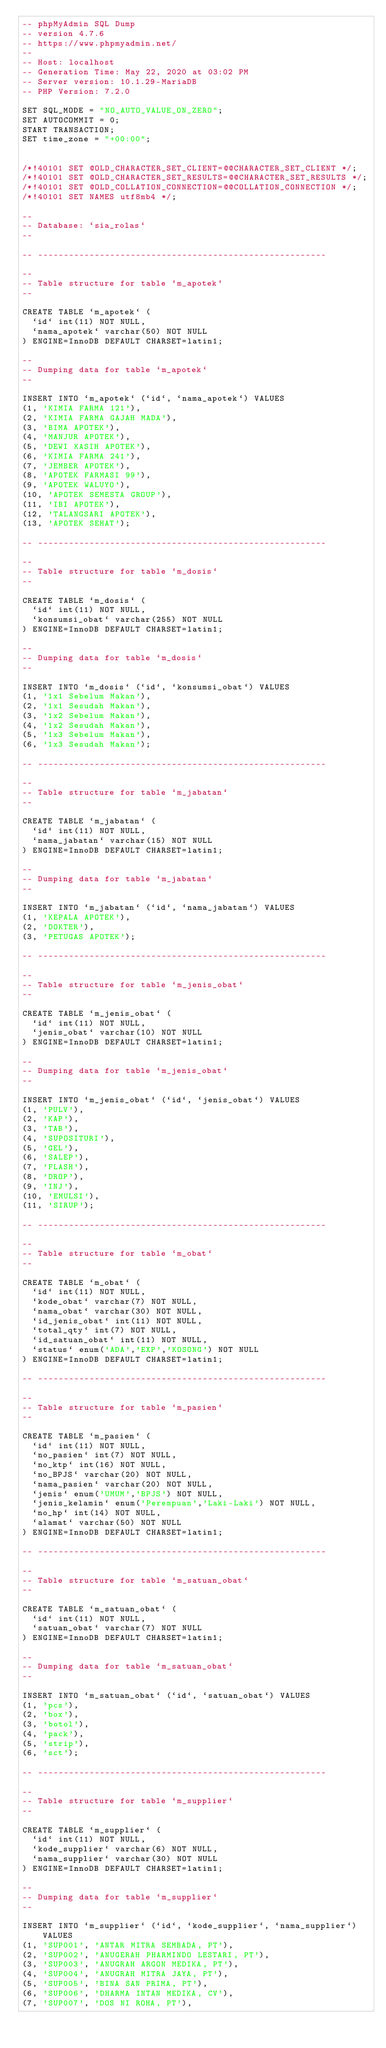Convert code to text. <code><loc_0><loc_0><loc_500><loc_500><_SQL_>-- phpMyAdmin SQL Dump
-- version 4.7.6
-- https://www.phpmyadmin.net/
--
-- Host: localhost
-- Generation Time: May 22, 2020 at 03:02 PM
-- Server version: 10.1.29-MariaDB
-- PHP Version: 7.2.0

SET SQL_MODE = "NO_AUTO_VALUE_ON_ZERO";
SET AUTOCOMMIT = 0;
START TRANSACTION;
SET time_zone = "+00:00";


/*!40101 SET @OLD_CHARACTER_SET_CLIENT=@@CHARACTER_SET_CLIENT */;
/*!40101 SET @OLD_CHARACTER_SET_RESULTS=@@CHARACTER_SET_RESULTS */;
/*!40101 SET @OLD_COLLATION_CONNECTION=@@COLLATION_CONNECTION */;
/*!40101 SET NAMES utf8mb4 */;

--
-- Database: `sia_rolas`
--

-- --------------------------------------------------------

--
-- Table structure for table `m_apotek`
--

CREATE TABLE `m_apotek` (
  `id` int(11) NOT NULL,
  `nama_apotek` varchar(50) NOT NULL
) ENGINE=InnoDB DEFAULT CHARSET=latin1;

--
-- Dumping data for table `m_apotek`
--

INSERT INTO `m_apotek` (`id`, `nama_apotek`) VALUES
(1, 'KIMIA FARMA 121'),
(2, 'KIMIA FARMA GAJAH MADA'),
(3, 'BIMA APOTEK'),
(4, 'MANJUR APOTEK'),
(5, 'DEWI KASIH APOTEK'),
(6, 'KIMIA FARMA 241'),
(7, 'JEMBER APOTEK'),
(8, 'APOTEK FARMASI 99'),
(9, 'APOTEK WALUYO'),
(10, 'APOTEK SEMESTA GROUP'),
(11, 'IBI APOTEK'),
(12, 'TALANGSARI APOTEK'),
(13, 'APOTEK SEHAT');

-- --------------------------------------------------------

--
-- Table structure for table `m_dosis`
--

CREATE TABLE `m_dosis` (
  `id` int(11) NOT NULL,
  `konsumsi_obat` varchar(255) NOT NULL
) ENGINE=InnoDB DEFAULT CHARSET=latin1;

--
-- Dumping data for table `m_dosis`
--

INSERT INTO `m_dosis` (`id`, `konsumsi_obat`) VALUES
(1, '1x1 Sebelum Makan'),
(2, '1x1 Sesudah Makan'),
(3, '1x2 Sebelum Makan'),
(4, '1x2 Sesudah Makan'),
(5, '1x3 Sebelum Makan'),
(6, '1x3 Sesudah Makan');

-- --------------------------------------------------------

--
-- Table structure for table `m_jabatan`
--

CREATE TABLE `m_jabatan` (
  `id` int(11) NOT NULL,
  `nama_jabatan` varchar(15) NOT NULL
) ENGINE=InnoDB DEFAULT CHARSET=latin1;

--
-- Dumping data for table `m_jabatan`
--

INSERT INTO `m_jabatan` (`id`, `nama_jabatan`) VALUES
(1, 'KEPALA APOTEK'),
(2, 'DOKTER'),
(3, 'PETUGAS APOTEK');

-- --------------------------------------------------------

--
-- Table structure for table `m_jenis_obat`
--

CREATE TABLE `m_jenis_obat` (
  `id` int(11) NOT NULL,
  `jenis_obat` varchar(10) NOT NULL
) ENGINE=InnoDB DEFAULT CHARSET=latin1;

--
-- Dumping data for table `m_jenis_obat`
--

INSERT INTO `m_jenis_obat` (`id`, `jenis_obat`) VALUES
(1, 'PULV'),
(2, 'KAP'),
(3, 'TAB'),
(4, 'SUPOSITURI'),
(5, 'GEL'),
(6, 'SALEP'),
(7, 'FLASH'),
(8, 'DROP'),
(9, 'INJ'),
(10, 'EMULSI'),
(11, 'SIRUP');

-- --------------------------------------------------------

--
-- Table structure for table `m_obat`
--

CREATE TABLE `m_obat` (
  `id` int(11) NOT NULL,
  `kode_obat` varchar(7) NOT NULL,
  `nama_obat` varchar(30) NOT NULL,
  `id_jenis_obat` int(11) NOT NULL,
  `total_qty` int(7) NOT NULL,
  `id_satuan_obat` int(11) NOT NULL,
  `status` enum('ADA','EXP','KOSONG') NOT NULL
) ENGINE=InnoDB DEFAULT CHARSET=latin1;

-- --------------------------------------------------------

--
-- Table structure for table `m_pasien`
--

CREATE TABLE `m_pasien` (
  `id` int(11) NOT NULL,
  `no_pasien` int(7) NOT NULL,
  `no_ktp` int(16) NOT NULL,
  `no_BPJS` varchar(20) NOT NULL,
  `nama_pasien` varchar(20) NOT NULL,
  `jenis` enum('UMUM','BPJS') NOT NULL,
  `jenis_kelamin` enum('Perempuan','Laki-Laki') NOT NULL,
  `no_hp` int(14) NOT NULL,
  `alamat` varchar(50) NOT NULL
) ENGINE=InnoDB DEFAULT CHARSET=latin1;

-- --------------------------------------------------------

--
-- Table structure for table `m_satuan_obat`
--

CREATE TABLE `m_satuan_obat` (
  `id` int(11) NOT NULL,
  `satuan_obat` varchar(7) NOT NULL
) ENGINE=InnoDB DEFAULT CHARSET=latin1;

--
-- Dumping data for table `m_satuan_obat`
--

INSERT INTO `m_satuan_obat` (`id`, `satuan_obat`) VALUES
(1, 'pcs'),
(2, 'box'),
(3, 'botol'),
(4, 'pack'),
(5, 'strip'),
(6, 'sct');

-- --------------------------------------------------------

--
-- Table structure for table `m_supplier`
--

CREATE TABLE `m_supplier` (
  `id` int(11) NOT NULL,
  `kode_supplier` varchar(6) NOT NULL,
  `nama_supplier` varchar(30) NOT NULL
) ENGINE=InnoDB DEFAULT CHARSET=latin1;

--
-- Dumping data for table `m_supplier`
--

INSERT INTO `m_supplier` (`id`, `kode_supplier`, `nama_supplier`) VALUES
(1, 'SUP001', 'ANTAR MITRA SEMBADA, PT'),
(2, 'SUP002', 'ANUGERAH PHARMINDO LESTARI, PT'),
(3, 'SUP003', 'ANUGRAH ARGON MEDIKA, PT'),
(4, 'SUP004', 'ANUGRAH MITRA JAYA, PT'),
(5, 'SUP005', 'BINA SAN PRIMA, PT'),
(6, 'SUP006', 'DHARMA INTAN MEDIKA, CV'),
(7, 'SUP007', 'DOS NI ROHA, PT'),</code> 